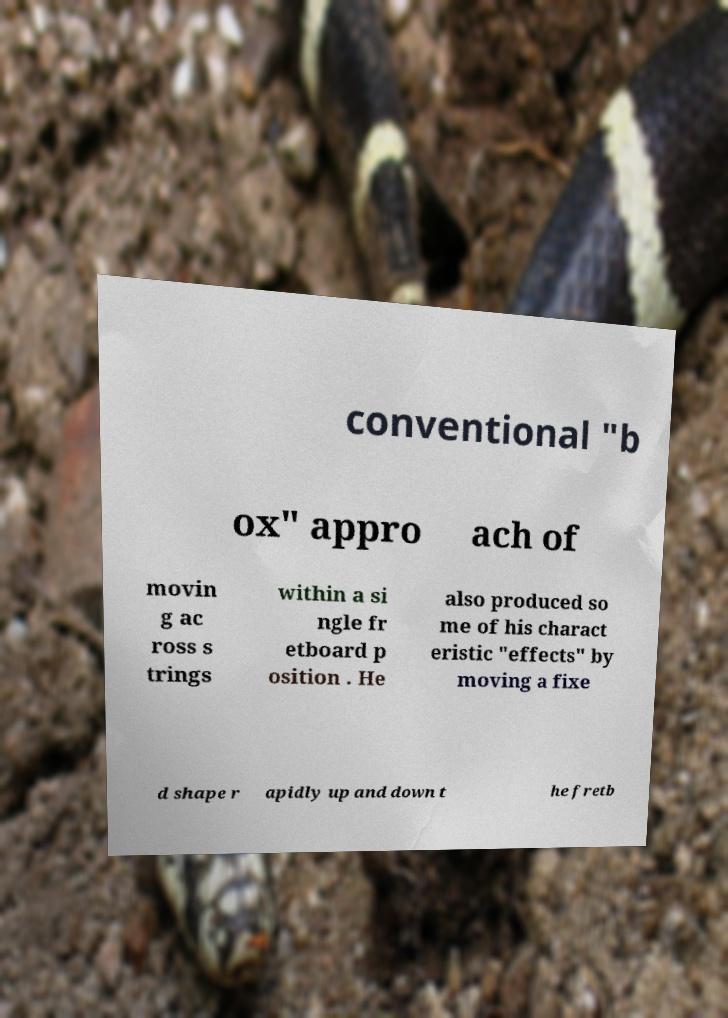I need the written content from this picture converted into text. Can you do that? conventional "b ox" appro ach of movin g ac ross s trings within a si ngle fr etboard p osition . He also produced so me of his charact eristic "effects" by moving a fixe d shape r apidly up and down t he fretb 